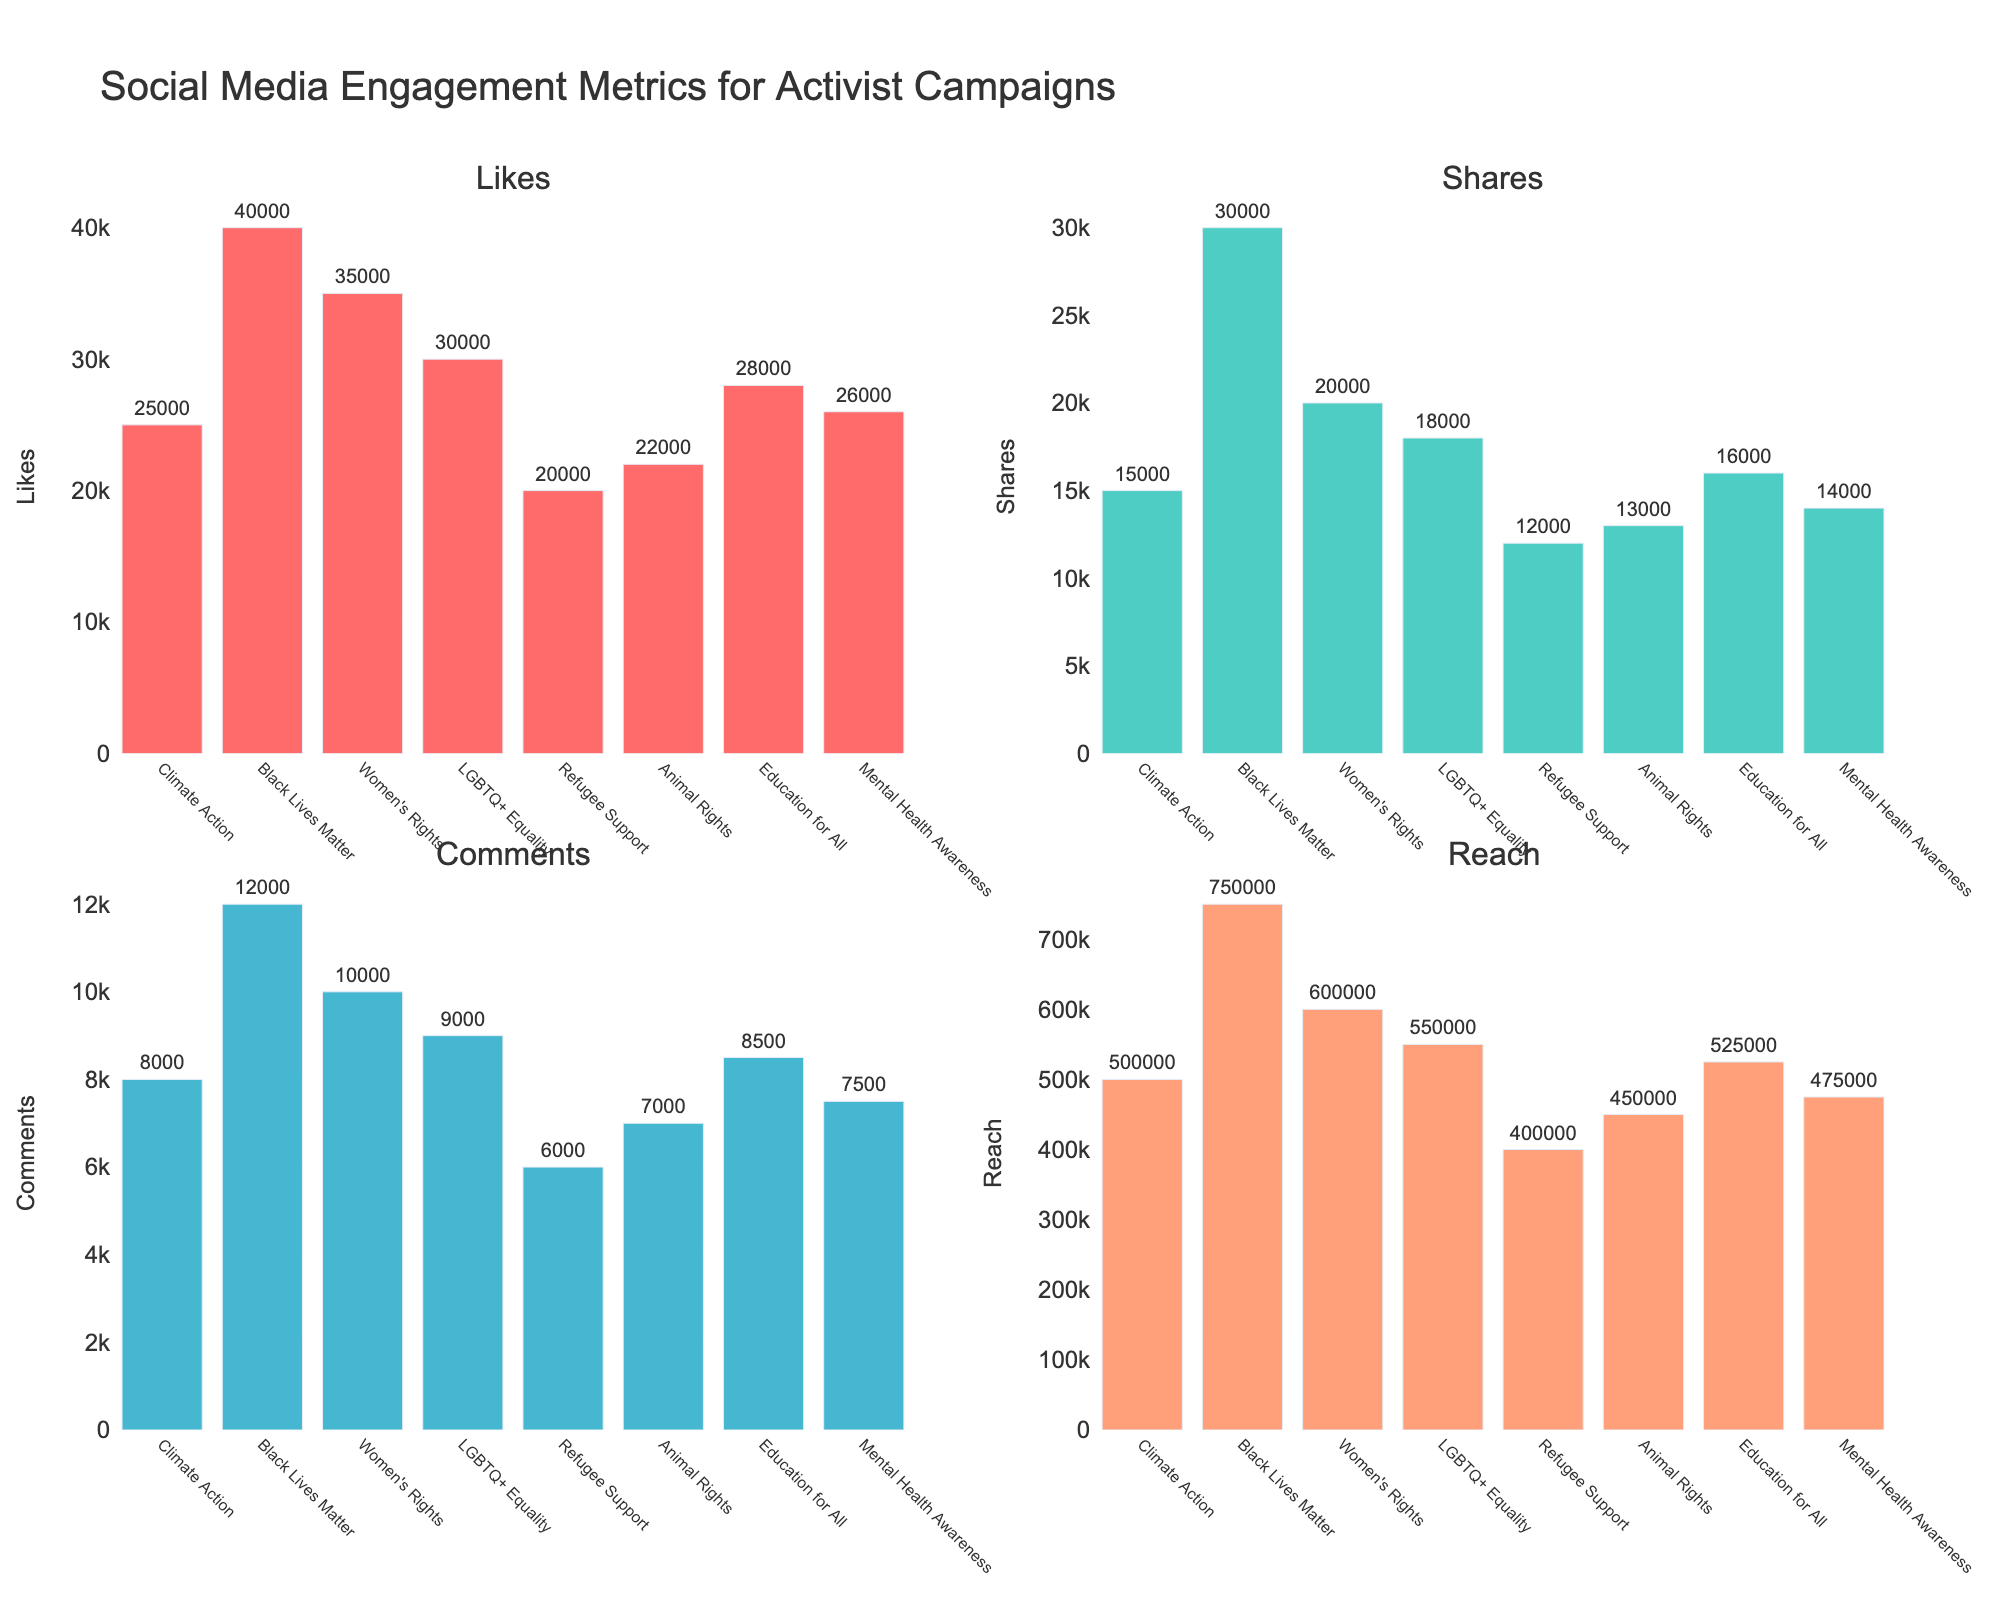What is the title of the figure? The title of the figure is usually displayed prominently at the top of the plot. In this case, it reads "Social Media Engagement Metrics for Activist Campaigns".
Answer: Social Media Engagement Metrics for Activist Campaigns How many different campaigns are represented in each subplot? By counting the number of distinct bars in any of the subplots, we can determine the number of different campaigns. In each subplot, there are eight distinct bars.
Answer: 8 Which campaign had the highest number of Likes? By examining the subplot for Likes, we can see that the bar representing "Black Lives Matter" is the tallest, indicating it has the highest number of Likes.
Answer: Black Lives Matter How many more Shares did the Women's Rights campaign receive compared to the Climate Action campaign? In the Shares subplot, Women's Rights has 20,000 Shares and Climate Action has 15,000 Shares. So, we subtract 15,000 from 20,000 to find the difference.
Answer: 5,000 Which campaign had the lowest Reach? By looking at the Reach subplot, the shortest bar represents the "Refugee Support" campaign, indicating it has the lowest Reach.
Answer: Refugee Support What is the average number of Comments across all campaigns? We sum the number of Comments for all campaigns and divide by the number of campaigns (8). The total is 8,000 + 12,000 + 10,000 + 9,000 + 6,000 + 7,000 + 8,500 + 7,500 = 68,000. The average is 68,000 / 8.
Answer: 8,500 Compare the Reach of Black Lives Matter and LGBTQ+ Equality campaigns. Which had higher Reach and by how much? In the Reach subplot, Black Lives Matter has 750,000 Reach and LGBTQ+ Equality has 550,000 Reach. Therefore, we subtract 550,000 from 750,000 to find the difference.
Answer: Black Lives Matter by 200,000 What is the sum of Likes for the Education for All and Mental Health Awareness campaigns? Referring to the Likes subplot, Education for All has 28,000 likes and Mental Health Awareness has 26,000 likes. Adding them together gives 28,000 + 26,000.
Answer: 54,000 How many data points are shown in total across all subplots? Since each subplot represents the same eight campaigns, and there are four subplots, we have a total of 8 campaigns * 4 metrics.
Answer: 32 Which campaign has more Comments: Animal Rights or Refugee Support? In the Comments subplot, the bar height for Animal Rights is 7,000, and for Refugee Support, it is 6,000. Comparing these values, Animal Rights has more Comments.
Answer: Animal Rights 